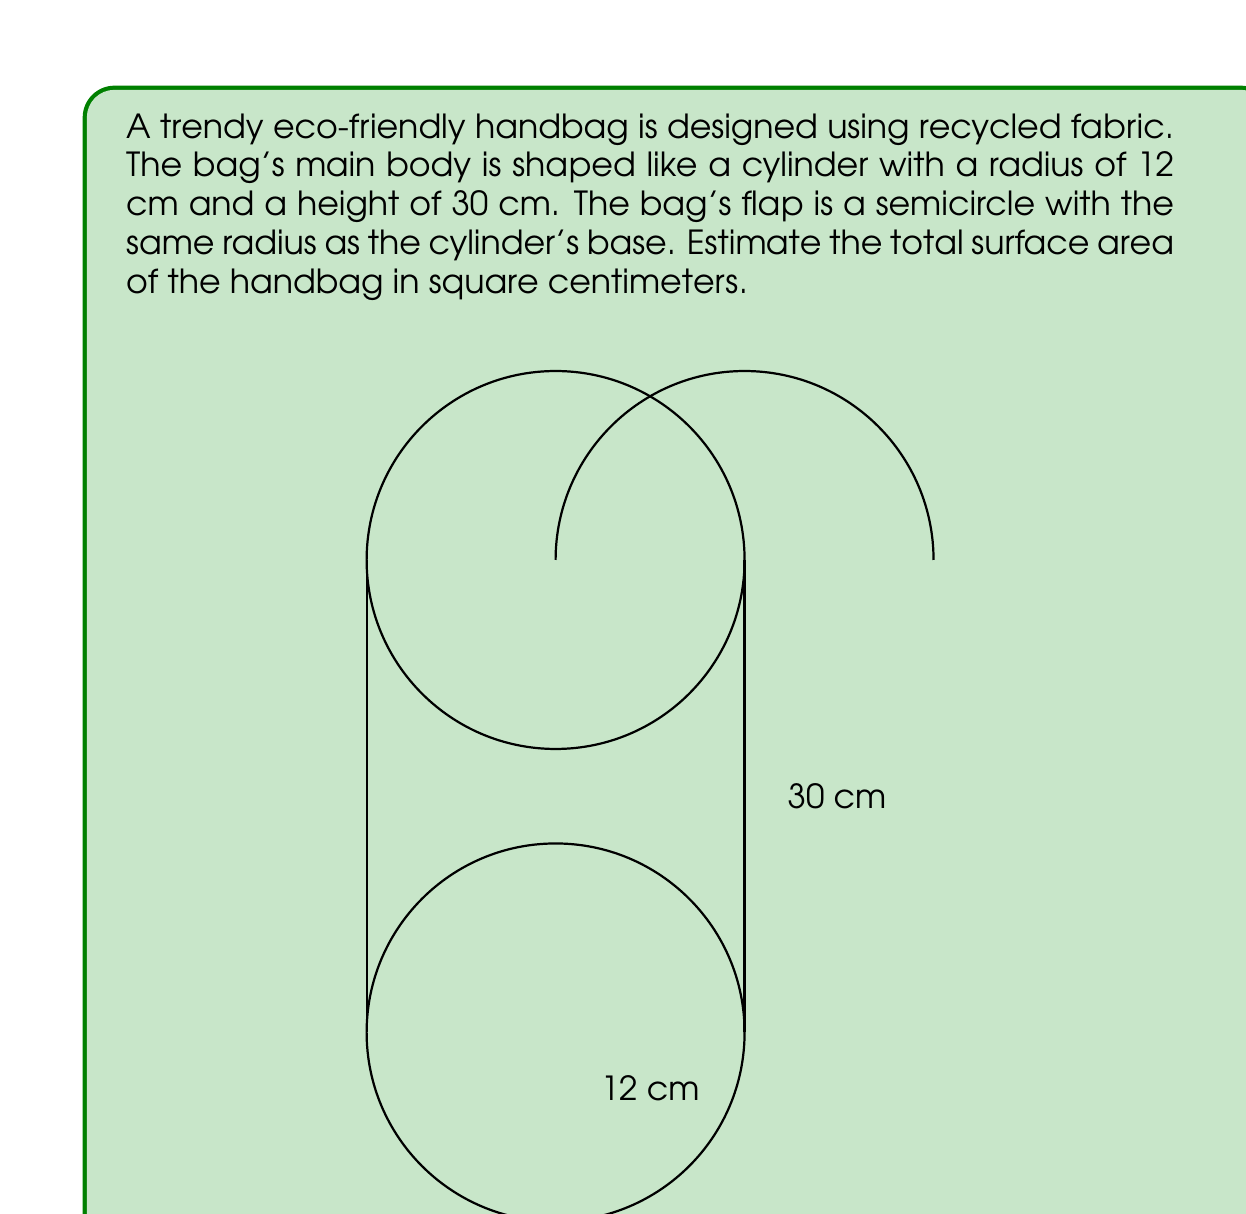Give your solution to this math problem. To estimate the surface area of the handbag, we need to calculate the areas of its components:

1. Cylinder surface area:
   - Lateral surface area: $A_l = 2\pi rh$
   - Base area: $A_b = \pi r^2$
   
2. Semicircle flap area: $A_f = \frac{1}{2}\pi r^2$

Step 1: Calculate the lateral surface area of the cylinder
$$A_l = 2\pi rh = 2\pi \cdot 12 \cdot 30 = 2260.80 \text{ cm}^2$$

Step 2: Calculate the area of one circular base
$$A_b = \pi r^2 = \pi \cdot 12^2 = 452.39 \text{ cm}^2$$

Step 3: Calculate the area of the semicircle flap
$$A_f = \frac{1}{2}\pi r^2 = \frac{1}{2} \cdot \pi \cdot 12^2 = 226.19 \text{ cm}^2$$

Step 4: Sum up all the areas to get the total surface area
$$A_{total} = A_l + A_b + A_f = 2260.80 + 452.39 + 226.19 = 2939.38 \text{ cm}^2$$

Therefore, the estimated total surface area of the handbag is approximately 2939.38 square centimeters.
Answer: $2939.38 \text{ cm}^2$ 